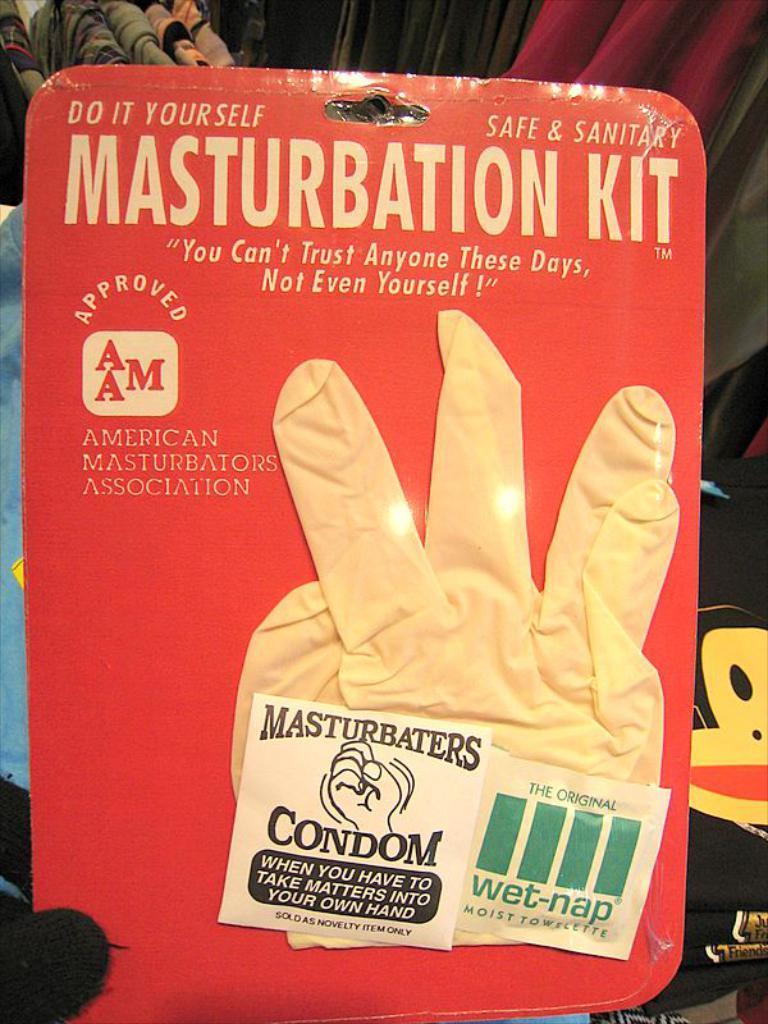How would you summarize this image in a sentence or two? In this image in the center there is one packet and in the packet there are some gloves and some text, in the background there are some clothes and a bag. 